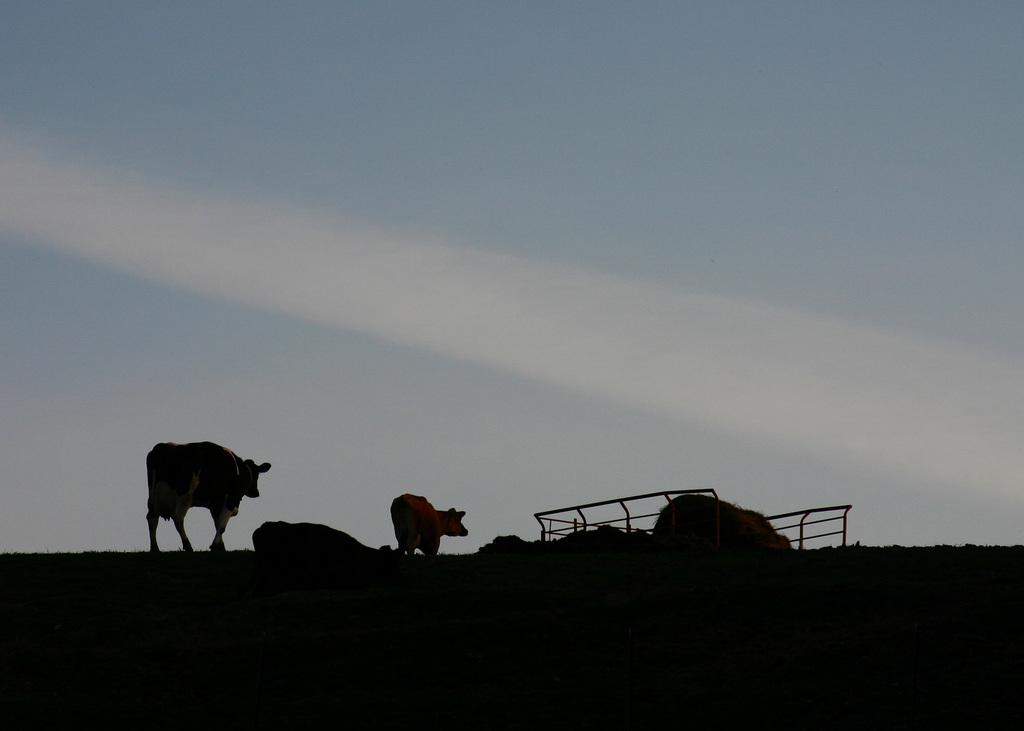What is the lighting condition at the bottom of the image? The image is dark at the bottom. What animals can be seen in the image? There are two cows standing on the ground. What type of vegetation is present in the image? Grass is present in the image. What can be seen in the sky in the image? Clouds are visible in the sky. What object is present in the image? There is an object in the image, but its specific nature is not mentioned in the facts. What type of bucket can be seen in the image? There is no bucket present in the image. Can you hear a whistle in the image? There is no sound or indication of a whistle in the image. 